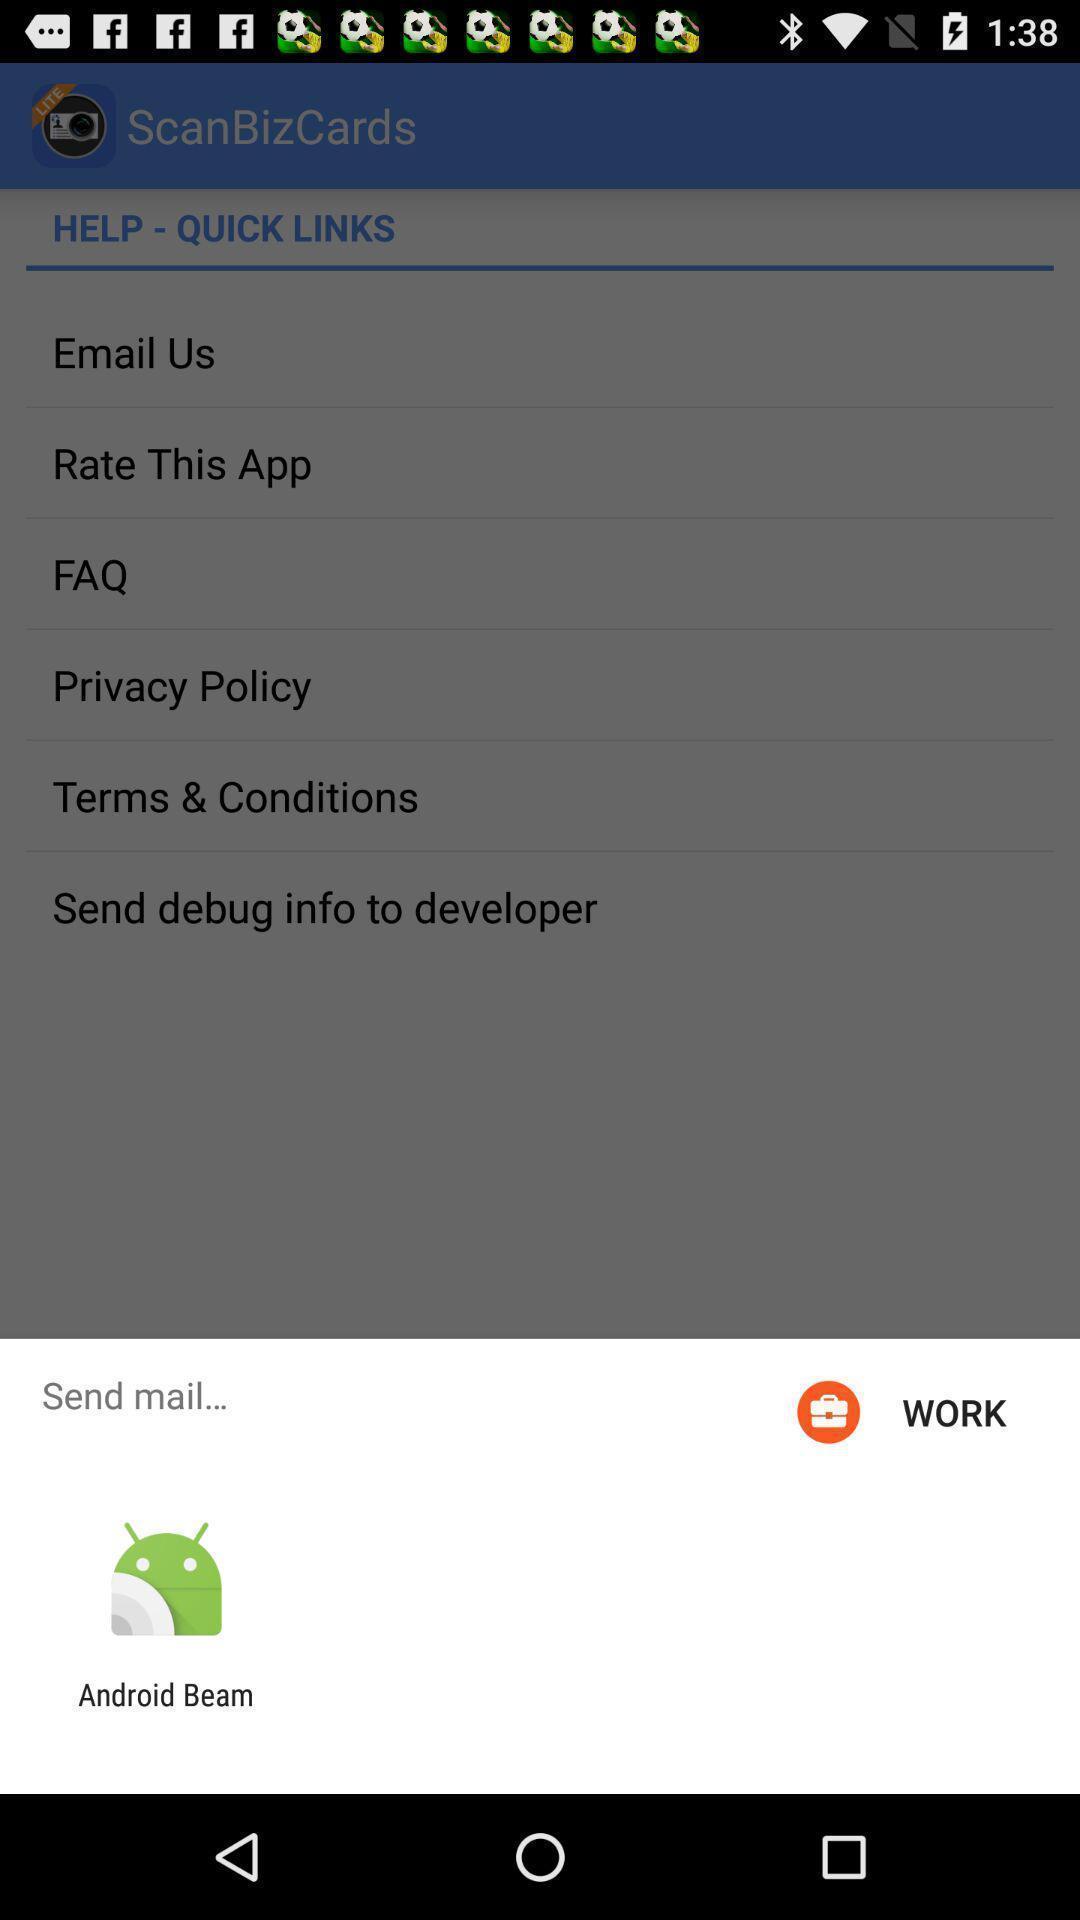What is the overall content of this screenshot? Popup to send mail for the business app. 